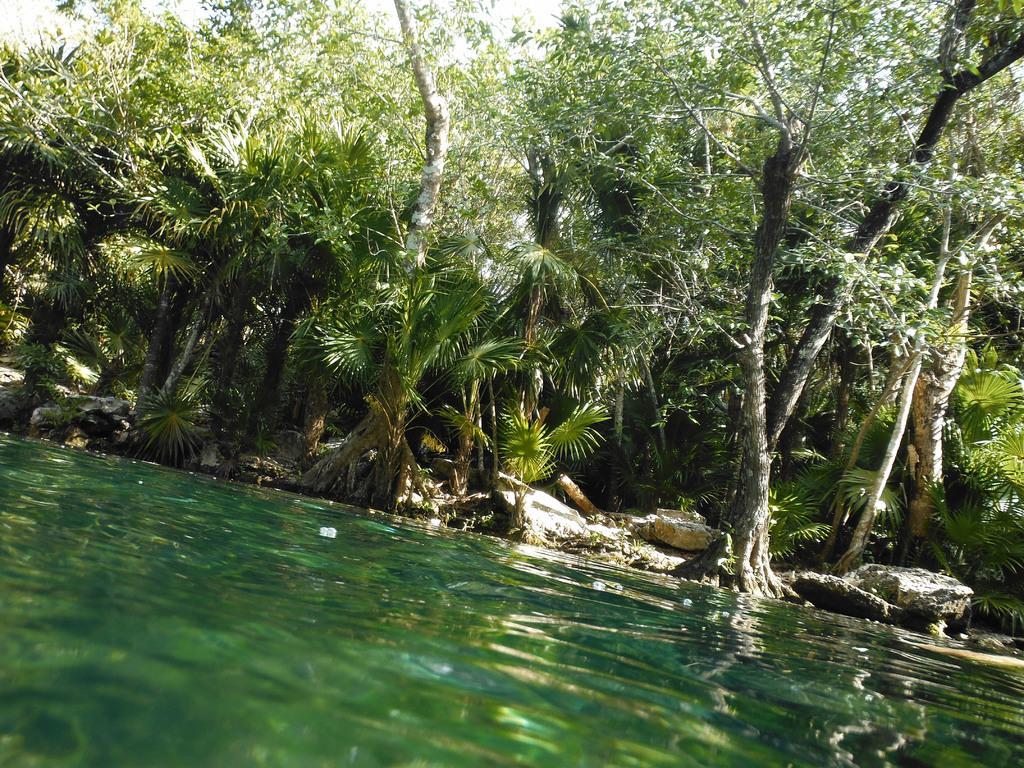Can you describe this image briefly? In this image we can see trees, sky and stones. At the bottom of the image we can see water. 